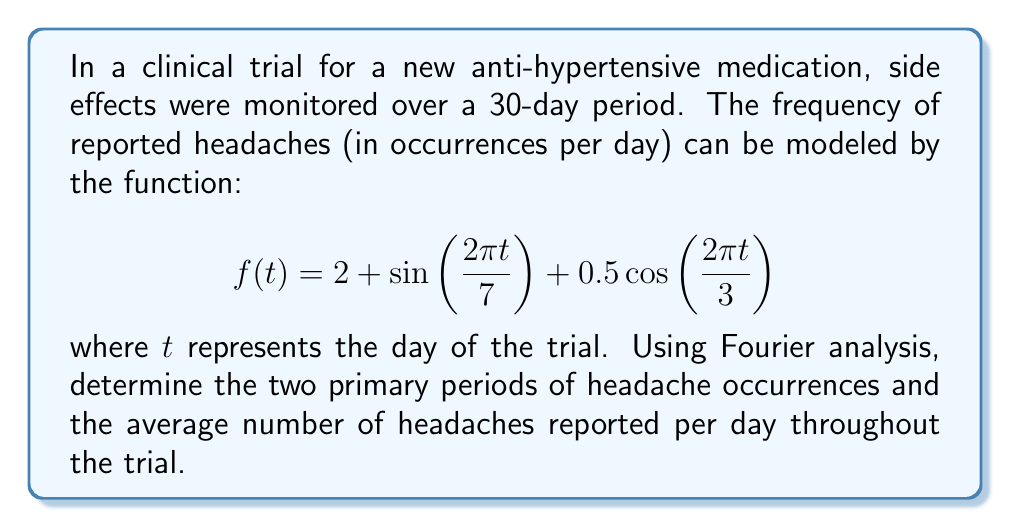Show me your answer to this math problem. To analyze the periodicity and average of the side effect occurrences, we'll examine the given function:

$$f(t) = 2 + \sin\left(\frac{2\pi t}{7}\right) + 0.5\cos\left(\frac{2\pi t}{3}\right)$$

1. Identifying periodic components:
   a) $\sin\left(\frac{2\pi t}{7}\right)$ has a period of 7 days
   b) $0.5\cos\left(\frac{2\pi t}{3}\right)$ has a period of 3 days

These are the two primary periods of headache occurrences.

2. Calculating the average number of headaches:
   The average is given by the constant term in the Fourier series, which in this case is 2.

Therefore, the average number of headaches reported per day throughout the trial is 2.

To verify this mathematically:

$$\text{Average} = \frac{1}{T}\int_0^T f(t)dt$$

Where $T$ is the overall period (least common multiple of 7 and 3, which is 21).

$$\begin{align}
\text{Average} &= \frac{1}{21}\int_0^{21} \left(2 + \sin\left(\frac{2\pi t}{7}\right) + 0.5\cos\left(\frac{2\pi t}{3}\right)\right)dt \\
&= \frac{1}{21}\left[2t - \frac{7}{2\pi}\cos\left(\frac{2\pi t}{7}\right) + \frac{3}{2\pi}\sin\left(\frac{2\pi t}{3}\right)\right]_0^{21} \\
&= \frac{1}{21}(42 - 0 + 0) \\
&= 2
\end{align}$$

This confirms that the average number of headaches per day is indeed 2.
Answer: The two primary periods of headache occurrences are 7 days and 3 days. The average number of headaches reported per day throughout the trial is 2. 